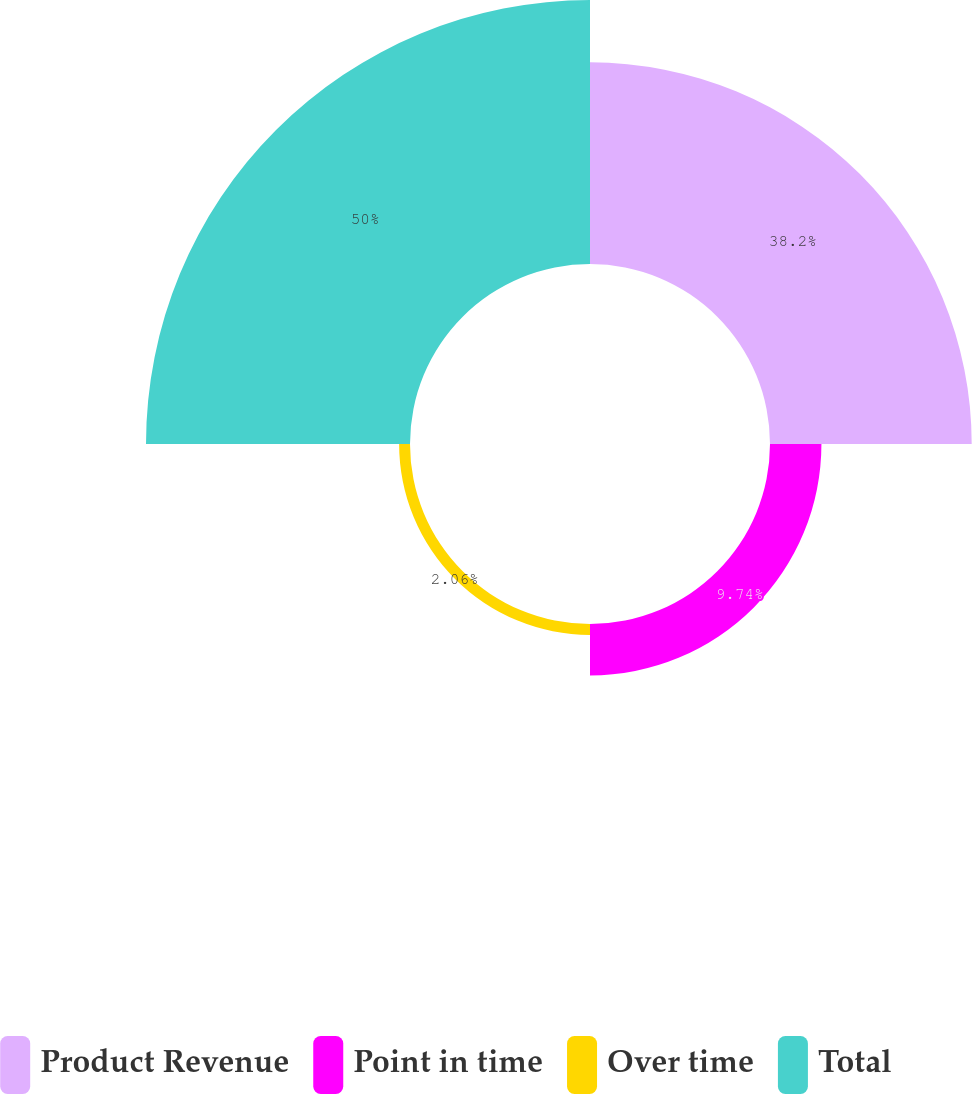Convert chart. <chart><loc_0><loc_0><loc_500><loc_500><pie_chart><fcel>Product Revenue<fcel>Point in time<fcel>Over time<fcel>Total<nl><fcel>38.2%<fcel>9.74%<fcel>2.06%<fcel>50.0%<nl></chart> 